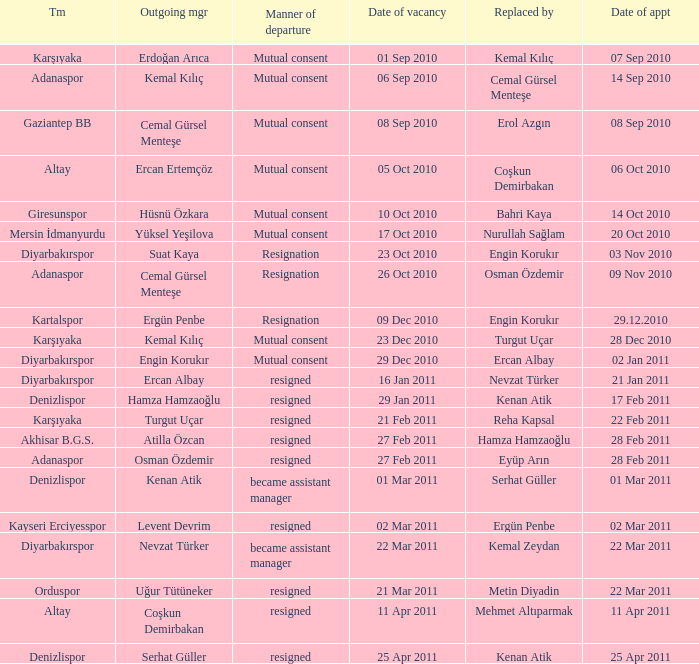When was the date of vacancy for the manager of Kartalspor?  09 Dec 2010. Write the full table. {'header': ['Tm', 'Outgoing mgr', 'Manner of departure', 'Date of vacancy', 'Replaced by', 'Date of appt'], 'rows': [['Karşıyaka', 'Erdoğan Arıca', 'Mutual consent', '01 Sep 2010', 'Kemal Kılıç', '07 Sep 2010'], ['Adanaspor', 'Kemal Kılıç', 'Mutual consent', '06 Sep 2010', 'Cemal Gürsel Menteşe', '14 Sep 2010'], ['Gaziantep BB', 'Cemal Gürsel Menteşe', 'Mutual consent', '08 Sep 2010', 'Erol Azgın', '08 Sep 2010'], ['Altay', 'Ercan Ertemçöz', 'Mutual consent', '05 Oct 2010', 'Coşkun Demirbakan', '06 Oct 2010'], ['Giresunspor', 'Hüsnü Özkara', 'Mutual consent', '10 Oct 2010', 'Bahri Kaya', '14 Oct 2010'], ['Mersin İdmanyurdu', 'Yüksel Yeşilova', 'Mutual consent', '17 Oct 2010', 'Nurullah Sağlam', '20 Oct 2010'], ['Diyarbakırspor', 'Suat Kaya', 'Resignation', '23 Oct 2010', 'Engin Korukır', '03 Nov 2010'], ['Adanaspor', 'Cemal Gürsel Menteşe', 'Resignation', '26 Oct 2010', 'Osman Özdemir', '09 Nov 2010'], ['Kartalspor', 'Ergün Penbe', 'Resignation', '09 Dec 2010', 'Engin Korukır', '29.12.2010'], ['Karşıyaka', 'Kemal Kılıç', 'Mutual consent', '23 Dec 2010', 'Turgut Uçar', '28 Dec 2010'], ['Diyarbakırspor', 'Engin Korukır', 'Mutual consent', '29 Dec 2010', 'Ercan Albay', '02 Jan 2011'], ['Diyarbakırspor', 'Ercan Albay', 'resigned', '16 Jan 2011', 'Nevzat Türker', '21 Jan 2011'], ['Denizlispor', 'Hamza Hamzaoğlu', 'resigned', '29 Jan 2011', 'Kenan Atik', '17 Feb 2011'], ['Karşıyaka', 'Turgut Uçar', 'resigned', '21 Feb 2011', 'Reha Kapsal', '22 Feb 2011'], ['Akhisar B.G.S.', 'Atilla Özcan', 'resigned', '27 Feb 2011', 'Hamza Hamzaoğlu', '28 Feb 2011'], ['Adanaspor', 'Osman Özdemir', 'resigned', '27 Feb 2011', 'Eyüp Arın', '28 Feb 2011'], ['Denizlispor', 'Kenan Atik', 'became assistant manager', '01 Mar 2011', 'Serhat Güller', '01 Mar 2011'], ['Kayseri Erciyesspor', 'Levent Devrim', 'resigned', '02 Mar 2011', 'Ergün Penbe', '02 Mar 2011'], ['Diyarbakırspor', 'Nevzat Türker', 'became assistant manager', '22 Mar 2011', 'Kemal Zeydan', '22 Mar 2011'], ['Orduspor', 'Uğur Tütüneker', 'resigned', '21 Mar 2011', 'Metin Diyadin', '22 Mar 2011'], ['Altay', 'Coşkun Demirbakan', 'resigned', '11 Apr 2011', 'Mehmet Altıparmak', '11 Apr 2011'], ['Denizlispor', 'Serhat Güller', 'resigned', '25 Apr 2011', 'Kenan Atik', '25 Apr 2011']]} 